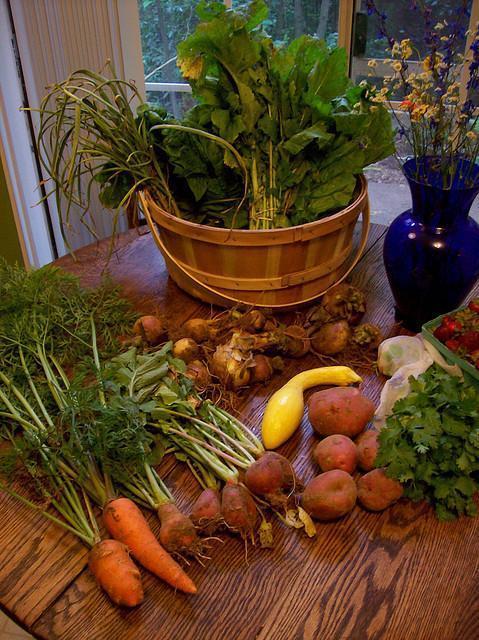How many carrots is for the soup?
Give a very brief answer. 2. How many squash?
Give a very brief answer. 1. How many carrots are there?
Give a very brief answer. 2. How many large elephants are standing?
Give a very brief answer. 0. 